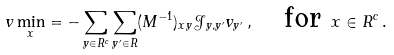Convert formula to latex. <formula><loc_0><loc_0><loc_500><loc_500>\ v \min _ { x } = - \sum _ { y \in R ^ { c } } \sum _ { y ^ { \prime } \in R } ( M ^ { - 1 } ) _ { x y } \mathcal { J } _ { y , y ^ { \prime } } v _ { y ^ { \prime } } \, , \quad \text {for } x \in R ^ { c } \, .</formula> 